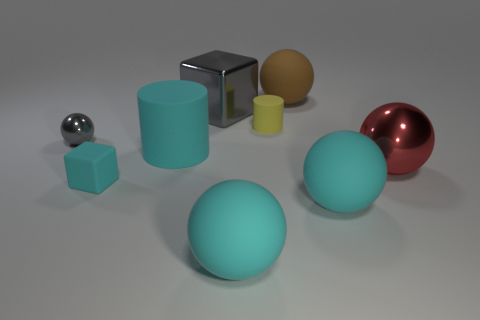What is the size of the matte block that is the same color as the big cylinder?
Give a very brief answer. Small. There is a matte sphere that is right of the big brown sphere; does it have the same color as the big metal cube?
Provide a short and direct response. No. What material is the cyan sphere that is on the left side of the rubber object behind the small yellow matte cylinder in front of the big brown thing made of?
Ensure brevity in your answer.  Rubber. Is there a big shiny thing of the same color as the big cylinder?
Keep it short and to the point. No. Is the number of rubber spheres on the left side of the small yellow cylinder less than the number of large matte cylinders?
Your answer should be compact. No. There is a block behind the red metallic thing; is its size the same as the small gray metal ball?
Offer a very short reply. No. What number of big cyan things are right of the large brown matte ball and left of the tiny matte cylinder?
Keep it short and to the point. 0. There is a cylinder that is to the left of the yellow rubber cylinder in front of the large metal cube; what size is it?
Give a very brief answer. Large. Are there fewer things behind the red sphere than big blocks that are in front of the small cyan thing?
Keep it short and to the point. No. There is a small matte thing that is in front of the tiny yellow cylinder; is its color the same as the large metal thing to the left of the large brown object?
Your response must be concise. No. 